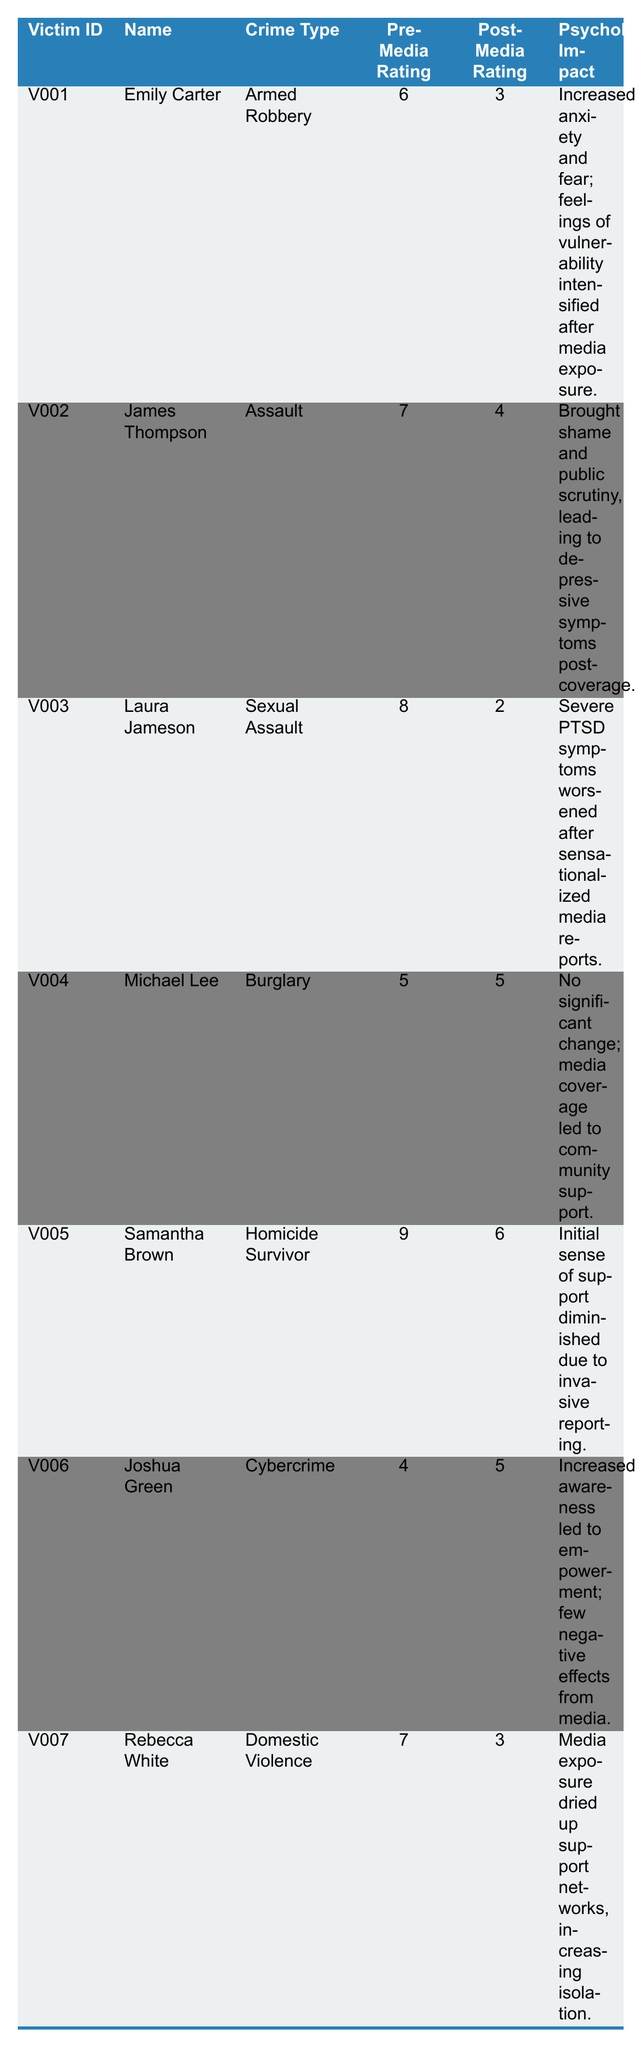What is the pre-media rating for Laura Jameson? Laura Jameson's pre-media rating is listed in the table as 8.
Answer: 8 How much did Emily Carter's psychological impact rating change post-media coverage? Emily Carter's pre-media rating was 6, and her post-media rating was 3. The change is calculated as 6 - 3 = 3.
Answer: 3 Did any victim have their post-media rating remain the same as their pre-media rating? Michael Lee's pre-media rating was 5, which is the same as his post-media rating of 5, indicating no change.
Answer: Yes What is the average pre-media rating for all victims? The pre-media ratings are 6, 7, 8, 5, 9, 4, and 7. The sum is (6 + 7 + 8 + 5 + 9 + 4 + 7) = 46. There are 7 victims, so the average is 46/7 ≈ 6.57.
Answer: Approximately 6.57 Which victim experienced the most significant decrease in their psychological impact rating post-media coverage? By comparing the differences between pre and post ratings, Laura Jameson had a decrease from 8 to 2 (6 points), which is the largest decrease.
Answer: Laura Jameson How many victims reported an increase in their post-media ratings compared to pre-media ratings? The only victim who experienced an increase was Joshua Green, whose rating went from 4 to 5, hence there is 1 victim.
Answer: 1 Was there a noticeable psychological impact for Rebecca White after the media coverage? Yes, Rebecca White's pre-media rating was 7, which decreased to 3 post-media coverage, leading to increased isolation and dried up support networks, indicating a noticeable negative impact.
Answer: Yes What was the psychological impact reported by Samantha Brown? Samantha Brown reported that her initial sense of support diminished due to invasive reporting after media coverage.
Answer: Initial sense of support diminished due to invasive reporting Which crime type had the highest pre-media rating among the victims? Laura Jameson experienced the highest pre-media rating of 8, which is the highest among all listed crime types.
Answer: Sexual Assault 